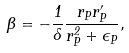<formula> <loc_0><loc_0><loc_500><loc_500>\Theta = - \frac { 1 } { \Lambda } \frac { r _ { P } r _ { P } ^ { \prime } } { r _ { P } ^ { 2 } + \epsilon _ { P } } ,</formula> 